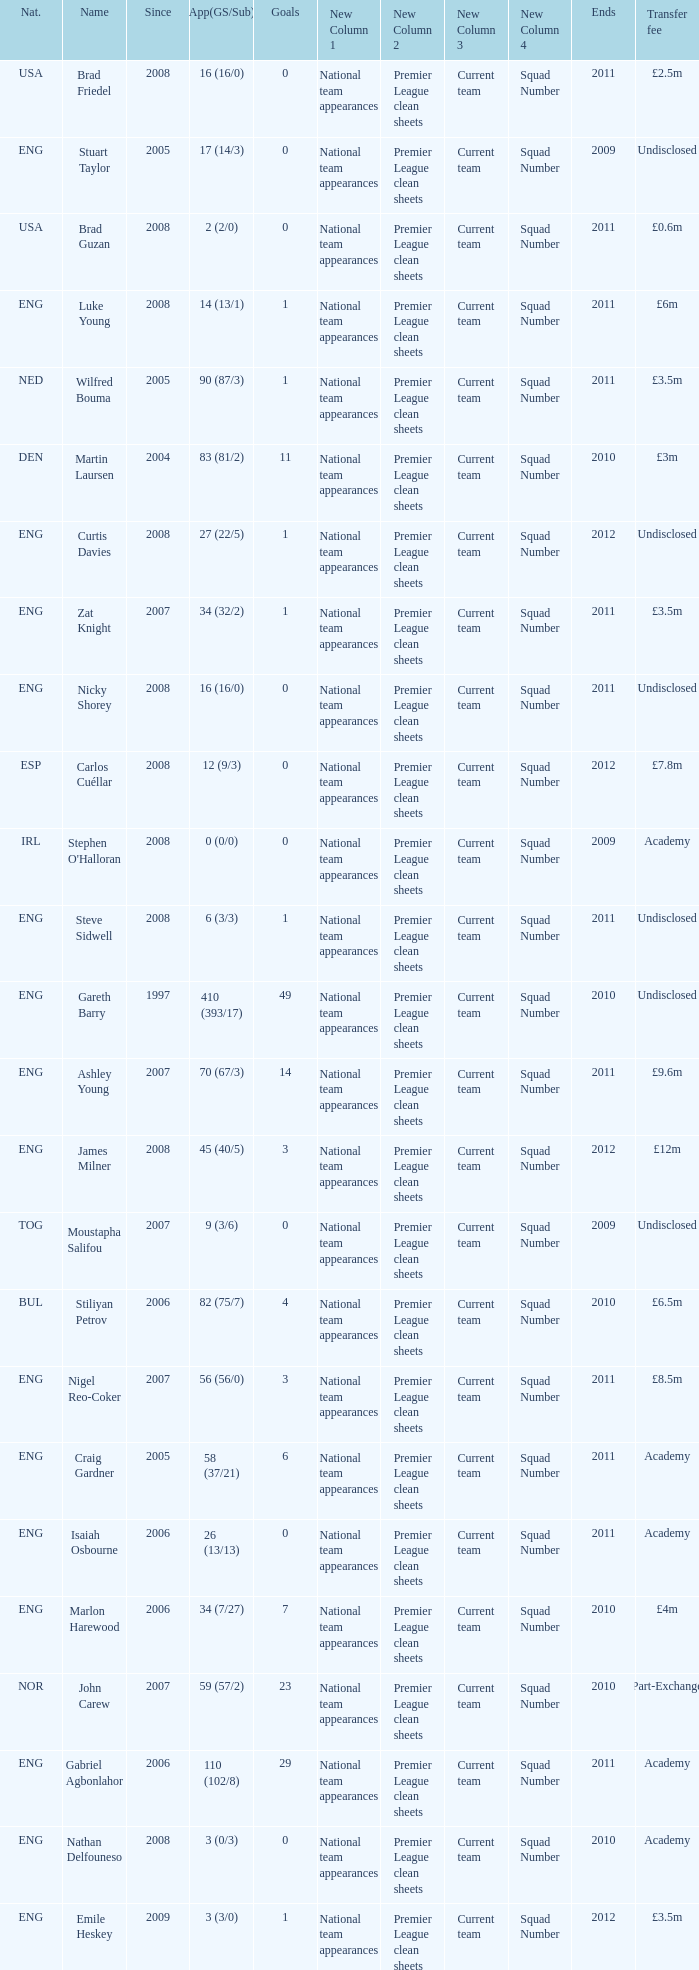When the transfer fee is £8.5m, what is the total ends? 2011.0. 